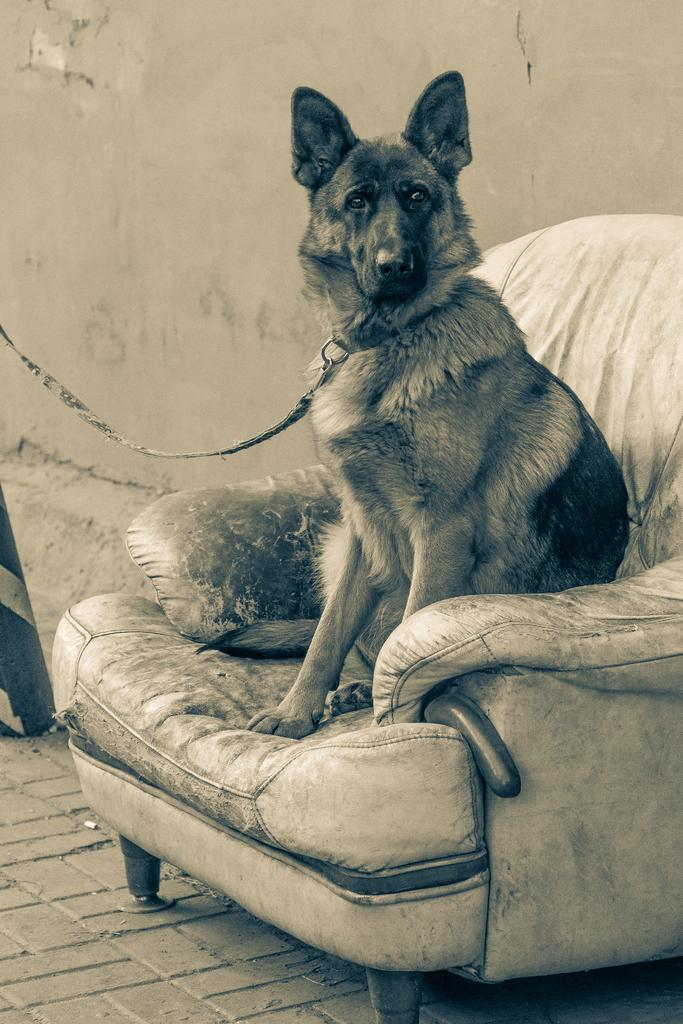What type of animal is in the image? There is a German shepherd dog in the image. What colors can be seen on the dog? The dog is brown and black in color. Where is the dog sitting in the image? The dog is sitting on a sofa. What can be seen in the background of the image? There is a white wall in the background of the image. How does the dog express its feeling of being in jail in the image? There is no indication in the image that the dog is in jail or expressing any feelings related to being in jail. 